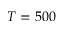<formula> <loc_0><loc_0><loc_500><loc_500>T = 5 0 0</formula> 